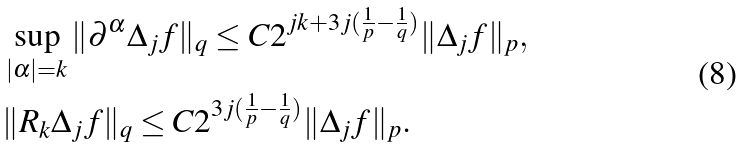<formula> <loc_0><loc_0><loc_500><loc_500>& \sup _ { | \alpha | = k } \| \partial ^ { \alpha } \Delta _ { j } f \| _ { q } \leq C 2 ^ { j k + 3 j ( \frac { 1 } { p } - \frac { 1 } { q } ) } \| \Delta _ { j } f \| _ { p } , \\ & \| R _ { k } \Delta _ { j } f \| _ { q } \leq C 2 ^ { 3 j ( \frac { 1 } { p } - \frac { 1 } { q } ) } \| \Delta _ { j } f \| _ { p } .</formula> 